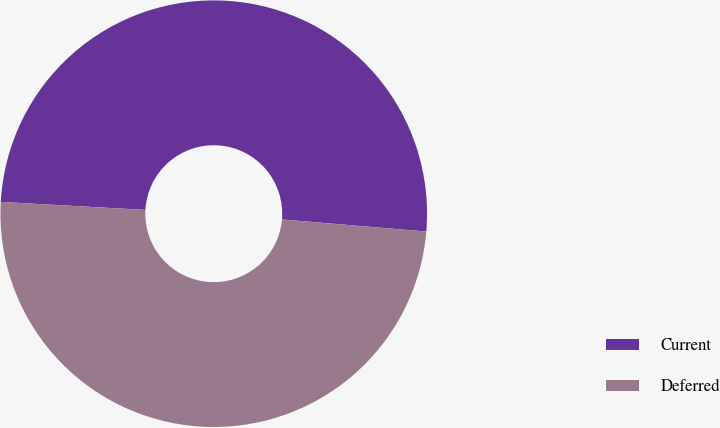<chart> <loc_0><loc_0><loc_500><loc_500><pie_chart><fcel>Current<fcel>Deferred<nl><fcel>50.45%<fcel>49.55%<nl></chart> 